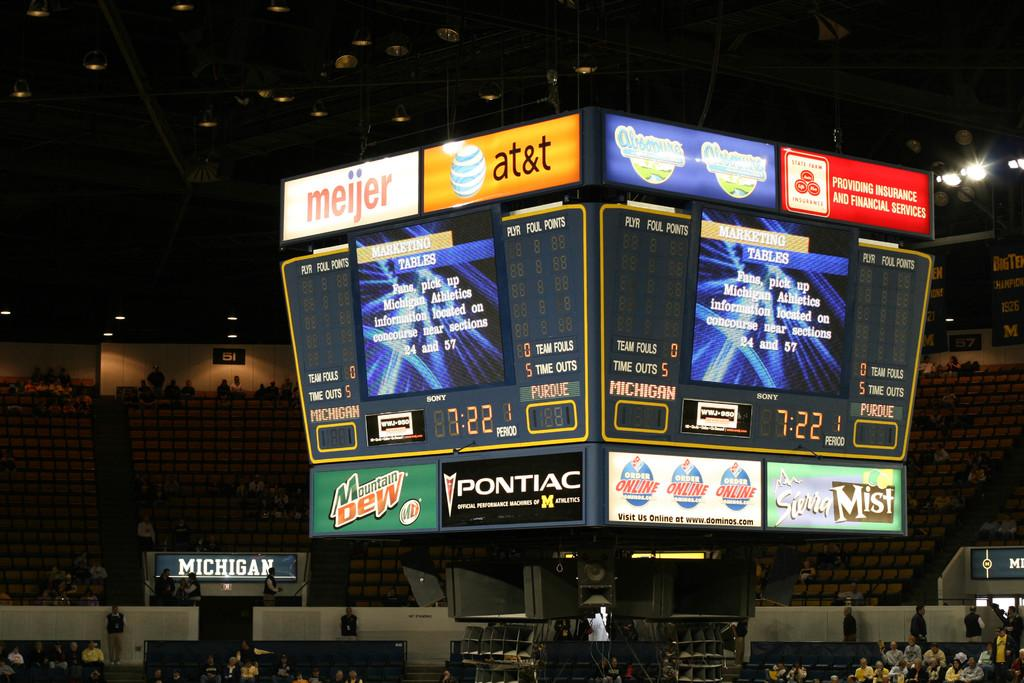Provide a one-sentence caption for the provided image. An arena scoreboard includes ads for Pontiac and AT&T. 